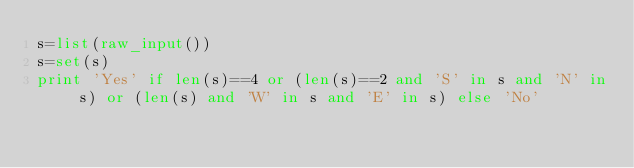Convert code to text. <code><loc_0><loc_0><loc_500><loc_500><_Python_>s=list(raw_input())
s=set(s)
print 'Yes' if len(s)==4 or (len(s)==2 and 'S' in s and 'N' in s) or (len(s) and 'W' in s and 'E' in s) else 'No'</code> 